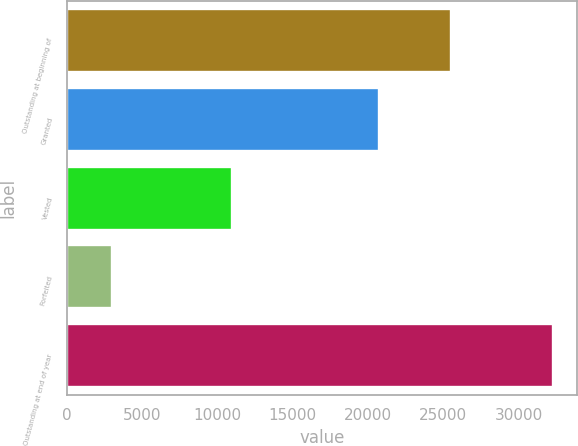Convert chart to OTSL. <chart><loc_0><loc_0><loc_500><loc_500><bar_chart><fcel>Outstanding at beginning of<fcel>Granted<fcel>Vested<fcel>Forfeited<fcel>Outstanding at end of year<nl><fcel>25532<fcel>20707<fcel>10966<fcel>3011<fcel>32262<nl></chart> 